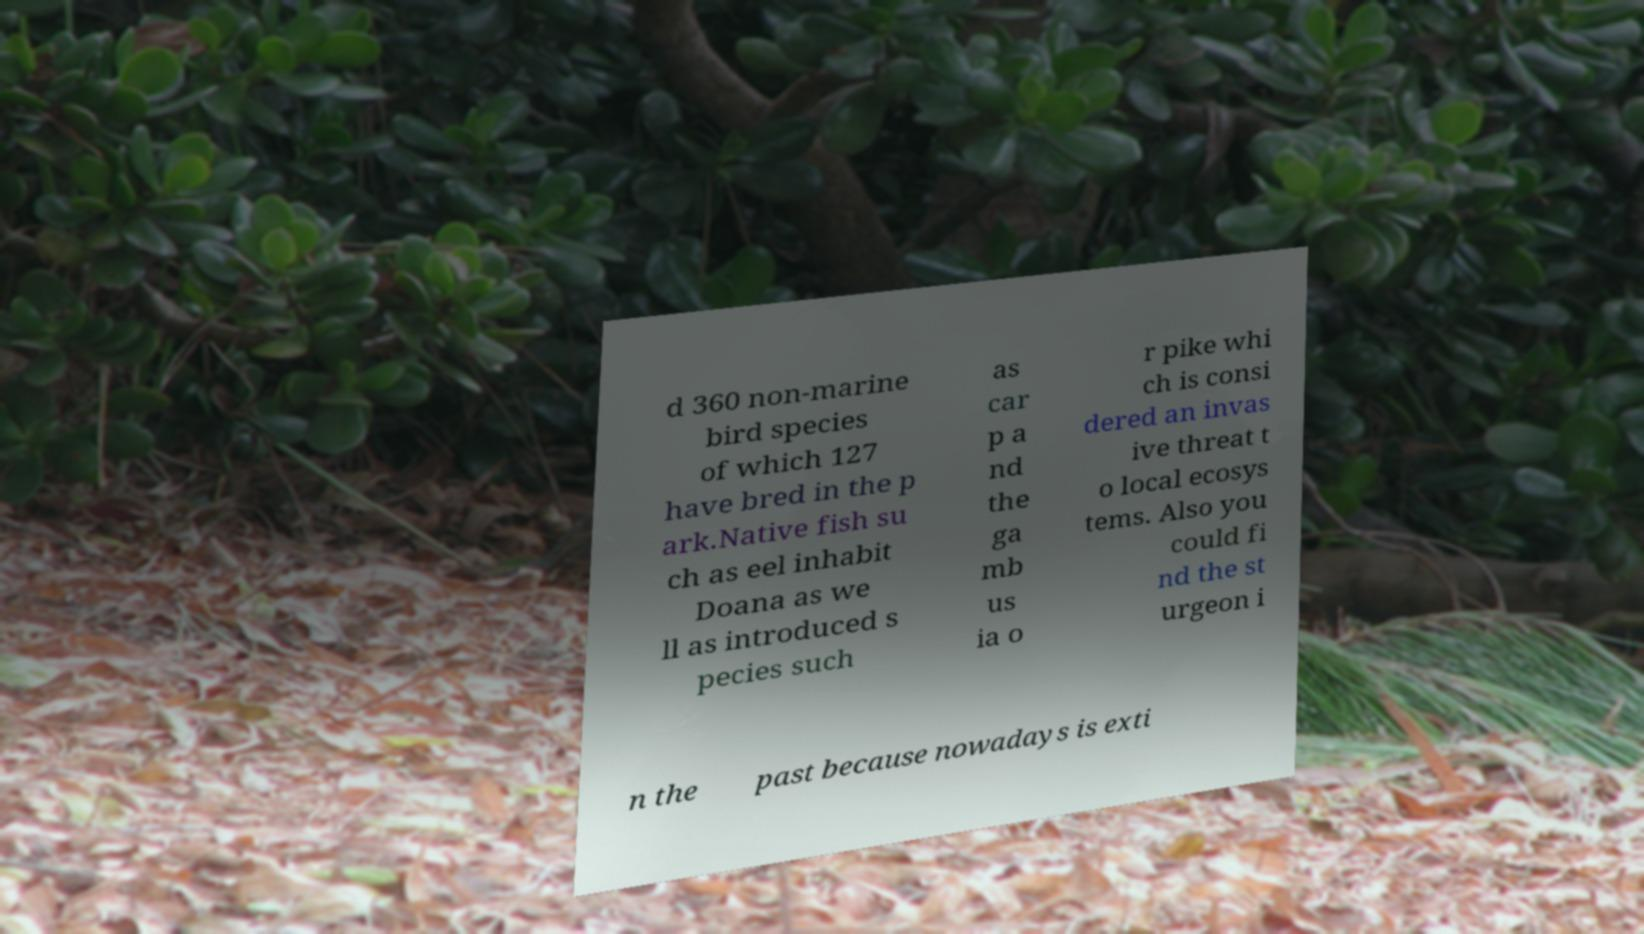Please read and relay the text visible in this image. What does it say? d 360 non-marine bird species of which 127 have bred in the p ark.Native fish su ch as eel inhabit Doana as we ll as introduced s pecies such as car p a nd the ga mb us ia o r pike whi ch is consi dered an invas ive threat t o local ecosys tems. Also you could fi nd the st urgeon i n the past because nowadays is exti 